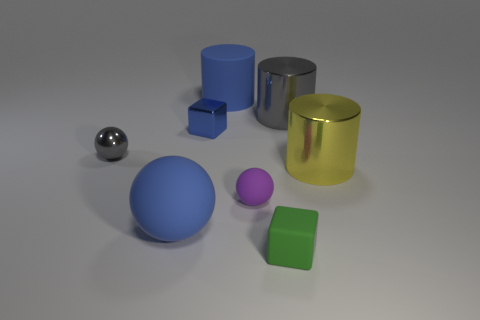Is the color of the big ball the same as the tiny metallic block?
Your answer should be compact. Yes. Does the tiny blue thing have the same material as the cylinder left of the green matte block?
Give a very brief answer. No. What is the color of the small rubber object that is to the right of the small matte thing behind the cube that is on the right side of the blue matte cylinder?
Your answer should be compact. Green. Is there anything else that has the same size as the purple matte ball?
Keep it short and to the point. Yes. There is a big rubber ball; is its color the same as the cylinder to the left of the green rubber cube?
Give a very brief answer. Yes. What color is the big ball?
Your response must be concise. Blue. What shape is the gray shiny thing that is to the right of the blue rubber object behind the gray thing that is on the right side of the blue rubber ball?
Give a very brief answer. Cylinder. How many other things are the same color as the large matte cylinder?
Provide a succinct answer. 2. Are there more small blue objects that are in front of the small blue shiny object than blue rubber cylinders in front of the purple rubber ball?
Ensure brevity in your answer.  No. Are there any tiny blue shiny things in front of the gray shiny sphere?
Offer a terse response. No. 